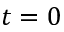Convert formula to latex. <formula><loc_0><loc_0><loc_500><loc_500>t = 0</formula> 